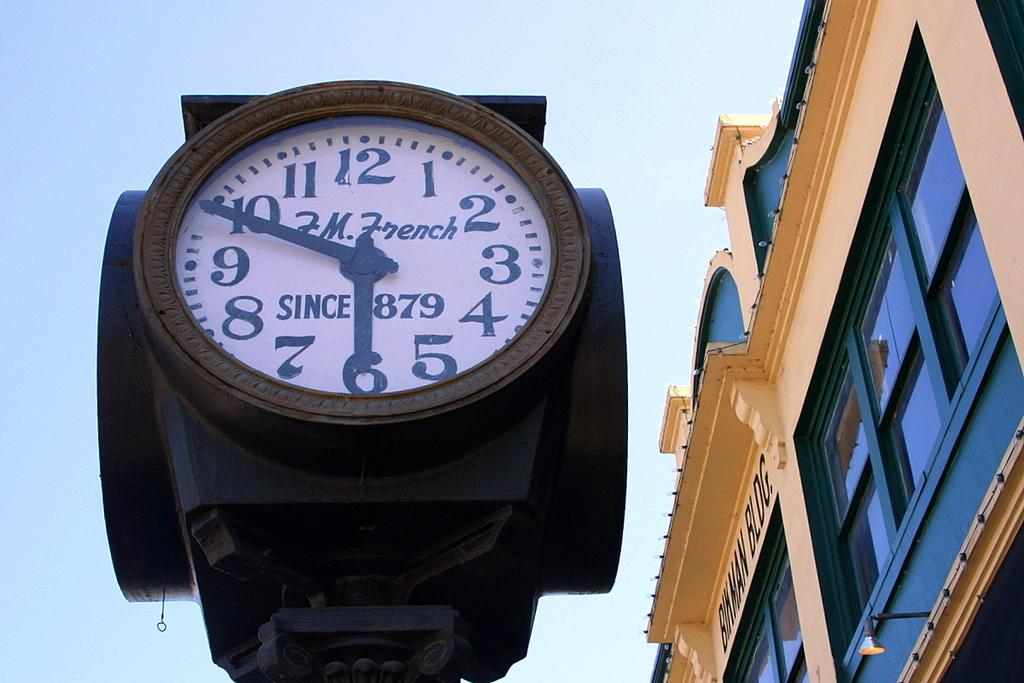<image>
Describe the image concisely. the F.M. French company has been making clocks since 1879 according to the clock hanging here 